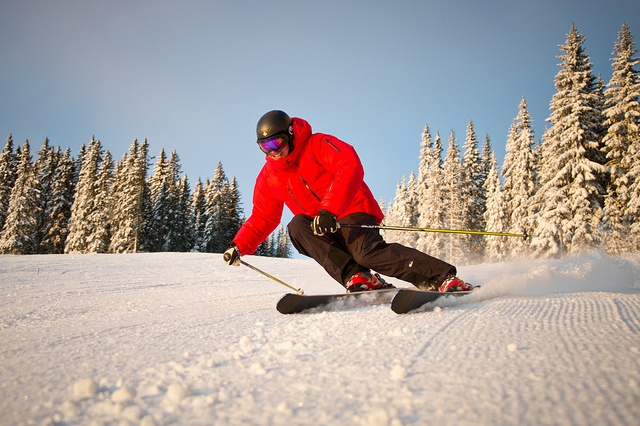Describe the objects in this image and their specific colors. I can see people in gray, red, black, maroon, and brown tones and skis in gray, black, and darkgray tones in this image. 